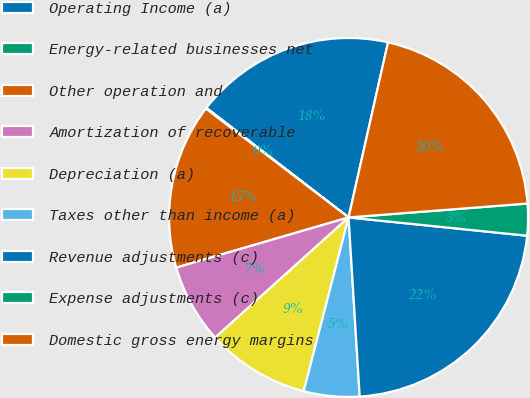<chart> <loc_0><loc_0><loc_500><loc_500><pie_chart><fcel>Operating Income (a)<fcel>Energy-related businesses net<fcel>Other operation and<fcel>Amortization of recoverable<fcel>Depreciation (a)<fcel>Taxes other than income (a)<fcel>Revenue adjustments (c)<fcel>Expense adjustments (c)<fcel>Domestic gross energy margins<nl><fcel>18.08%<fcel>0.08%<fcel>14.88%<fcel>7.16%<fcel>9.31%<fcel>5.01%<fcel>22.39%<fcel>2.86%<fcel>20.24%<nl></chart> 